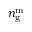<formula> <loc_0><loc_0><loc_500><loc_500>n _ { g } ^ { m }</formula> 